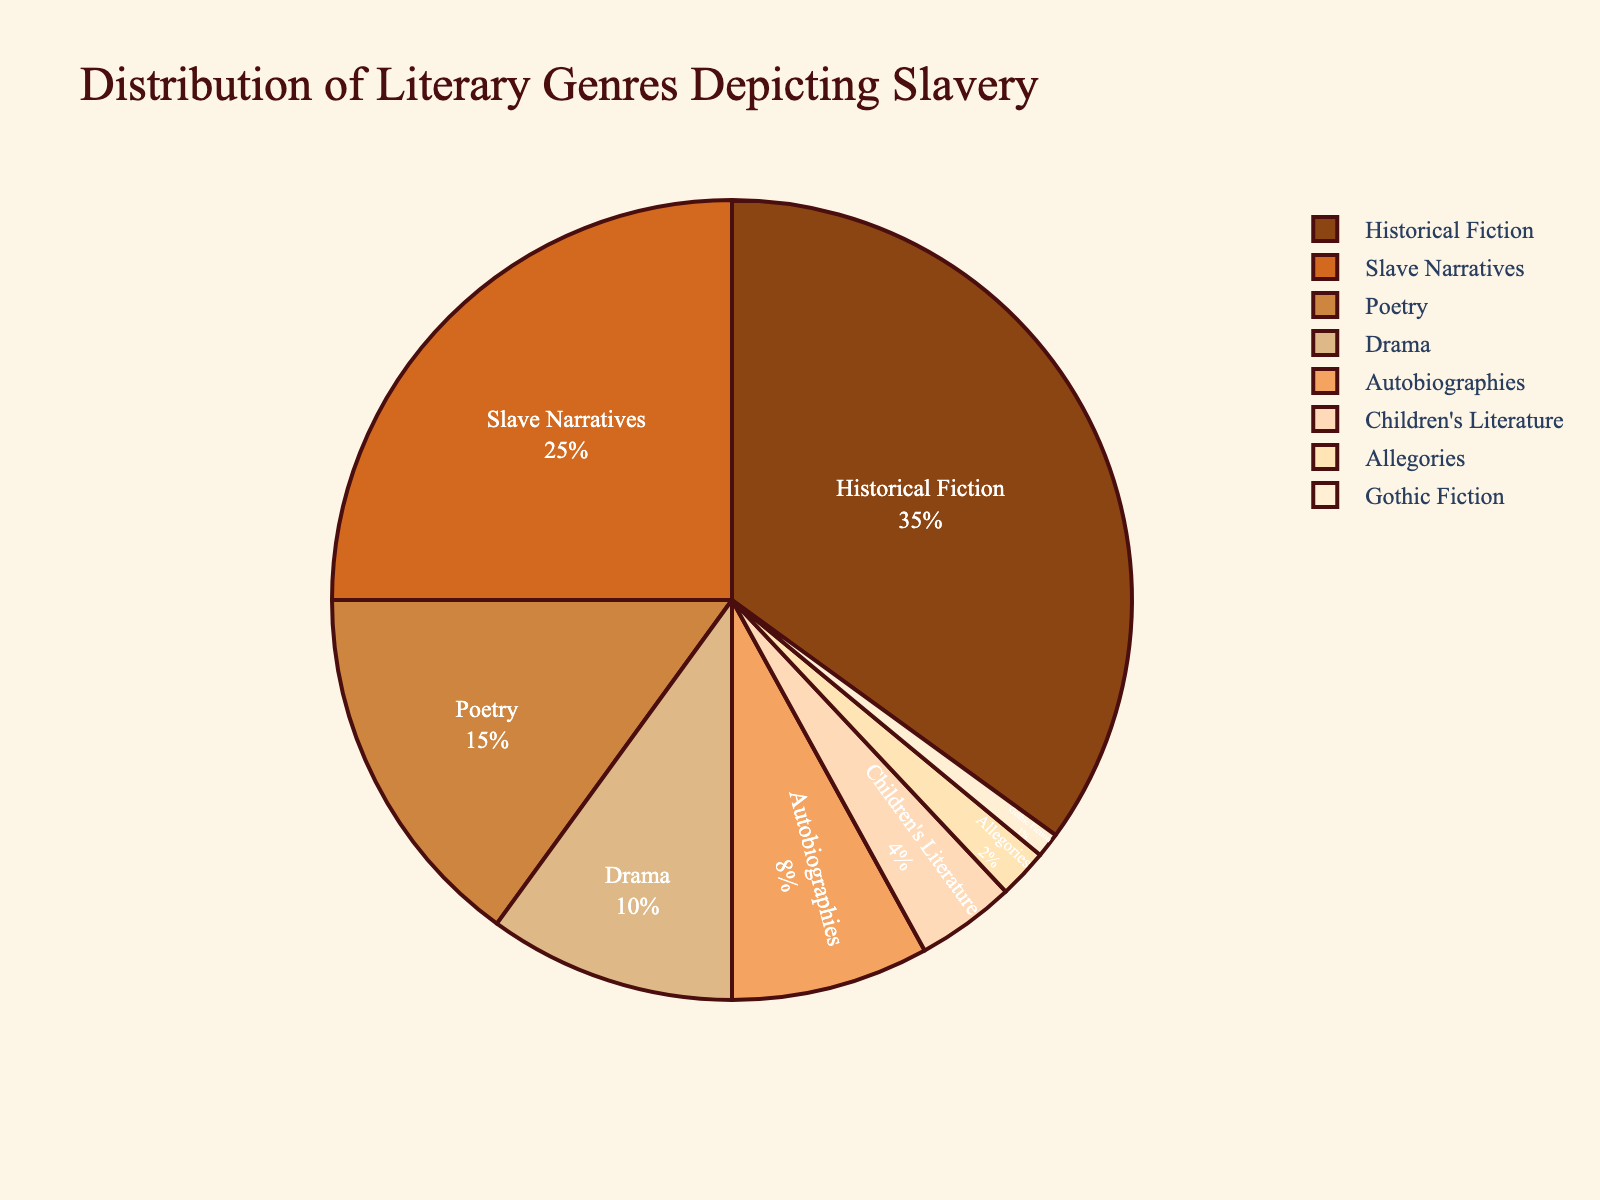Which literary genre has the largest percentage in depicting slavery? Refer to the pie chart and identify the genre with the largest slice. Historical Fiction has the largest percentage. The chart shows that Historical Fiction accounts for 35% of the total.
Answer: Historical Fiction Which two genres together account for 60% of the depictions? The chart indicates each genre's percentage, so adding the percentages of Historical Fiction (35%) and Slave Narratives (25%) gives 60%.
Answer: Historical Fiction and Slave Narratives By how much percentage does Historical Fiction exceed Poetry in the depiction of slavery? First, identify the percentages of Historical Fiction (35%) and Poetry (15%) from the chart. Then, subtract Poetry's percentage from Historical Fiction's: 35% - 15% = 20%.
Answer: 20% What is the combined percentage of the genres that have less than 10% representation each? Identify the genres with less than 10%: Drama (10% not included), Autobiographies (8%), Children's Literature (4%), Allegories (2%), Gothic Fiction (1%). Summing them: 8% + 4% + 2% + 1% = 15%.
Answer: 15% Which genre has the smallest representation, and what is its percentage? Identify the smallest slice in the pie chart, which corresponds to Gothic Fiction with 1%.
Answer: Gothic Fiction, 1% How does the percentage of Slave Narratives compare to the combined percentage of Drama and Poetry? Identify the percentages of Slave Narratives (25%), Drama (10%), and Poetry (15%). Then sum Drama and Poetry: 10% + 15% = 25%. Therefore, Slave Narratives (25%) is equal to the combined percentage of Drama and Poetry (25%).
Answer: Equal Which three genres together account for more than half of the total percentage? Examine the chart for three genres whose combined percentage exceeds 50%. Historical Fiction (35%), Slave Narratives (25%), and Poetry (15%). Summing them: 35% + 25% + 15% = 75%.
Answer: Historical Fiction, Slave Narratives, Poetry What percentage of the depictions is attributed to genres under Children's Literature? Identify Children's Literature's percentage (4%) and sum the genres below it: Allegories (2%) and Gothic Fiction (1%). Sum these: 2% + 1% = 3%.
Answer: 3% 